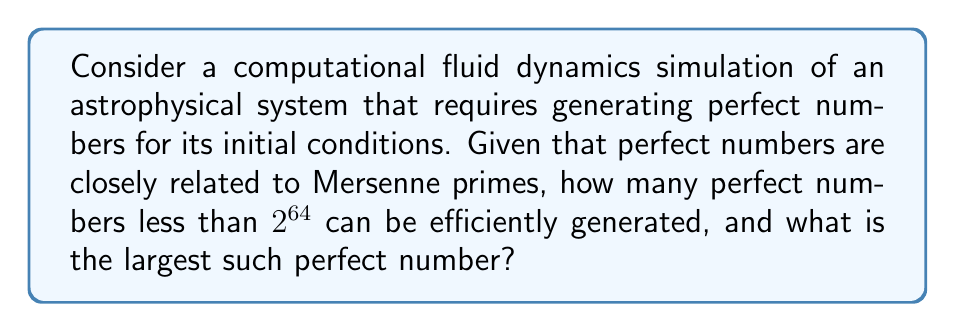Could you help me with this problem? Let's approach this step-by-step:

1) Perfect numbers are closely related to Mersenne primes. A Mersenne prime is a prime number of the form $M_p = 2^p - 1$, where $p$ is also prime.

2) Euclid proved that if $M_p = 2^p - 1$ is prime, then $N = 2^{p-1}(2^p - 1)$ is perfect.

3) As of 2023, only 51 Mersenne primes are known. However, we're interested in perfect numbers less than $2^{64}$.

4) Let's consider the perfect numbers generated by the first few Mersenne primes:

   For $p = 2$: $M_2 = 3$, $N_1 = 2^1(2^2 - 1) = 6$
   For $p = 3$: $M_3 = 7$, $N_2 = 2^2(2^3 - 1) = 28$
   For $p = 5$: $M_5 = 31$, $N_3 = 2^4(2^5 - 1) = 496$
   For $p = 7$: $M_7 = 127$, $N_4 = 2^6(2^7 - 1) = 8,128$
   For $p = 13$: $M_{13} = 8,191$, $N_5 = 2^{12}(2^{13} - 1) = 33,550,336$
   For $p = 17$: $M_{17} = 131,071$, $N_6 = 2^{16}(2^{17} - 1) = 8,589,869,056$
   For $p = 19$: $M_{19} = 524,287$, $N_7 = 2^{18}(2^{19} - 1) = 137,438,691,328$

5) The next perfect number would be for $p = 31$, which gives:
   $N_8 = 2^{30}(2^{31} - 1) = 2,305,843,008,139,952,128$

6) This number is greater than $2^{64} = 18,446,744,073,709,551,616$

Therefore, there are 7 perfect numbers less than $2^{64}$, and the largest one is $137,438,691,328$.
Answer: 7 perfect numbers; largest is 137,438,691,328 